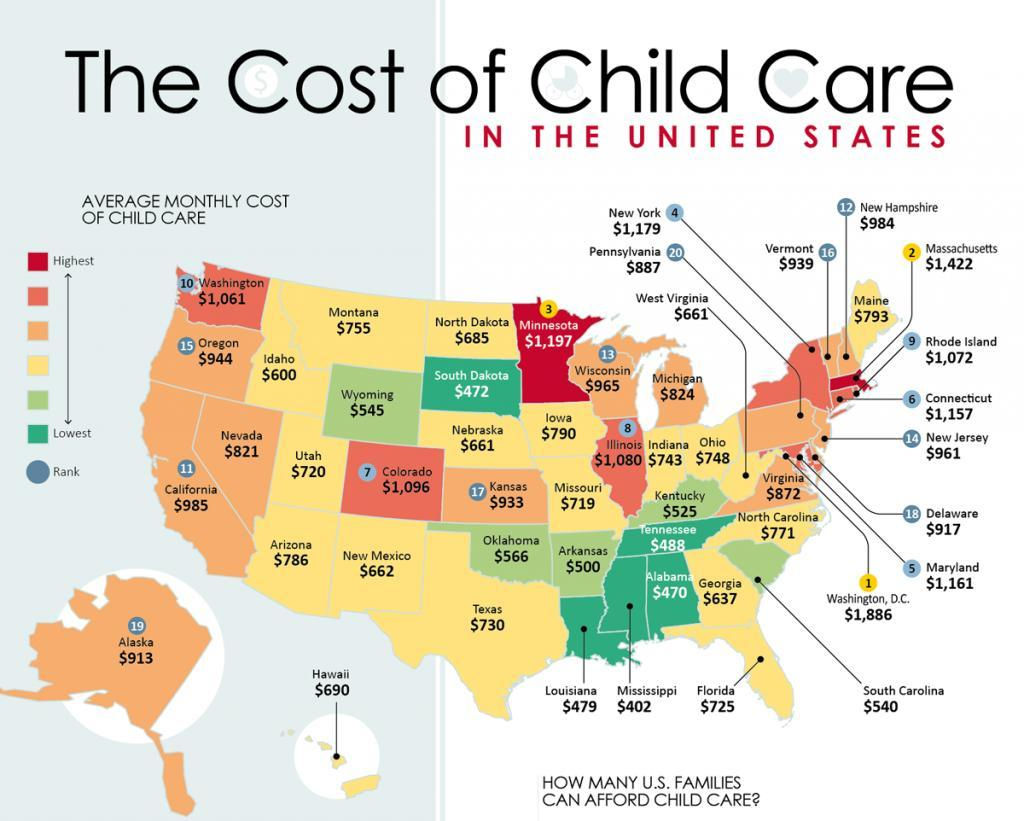Which place has highest average monthly cost of childcare?
Answer the question with a short phrase. Washington, D.C. What colour is the state of Maine- yellow, red or green? Yellow Which state has least childcare cost? Mississippi 